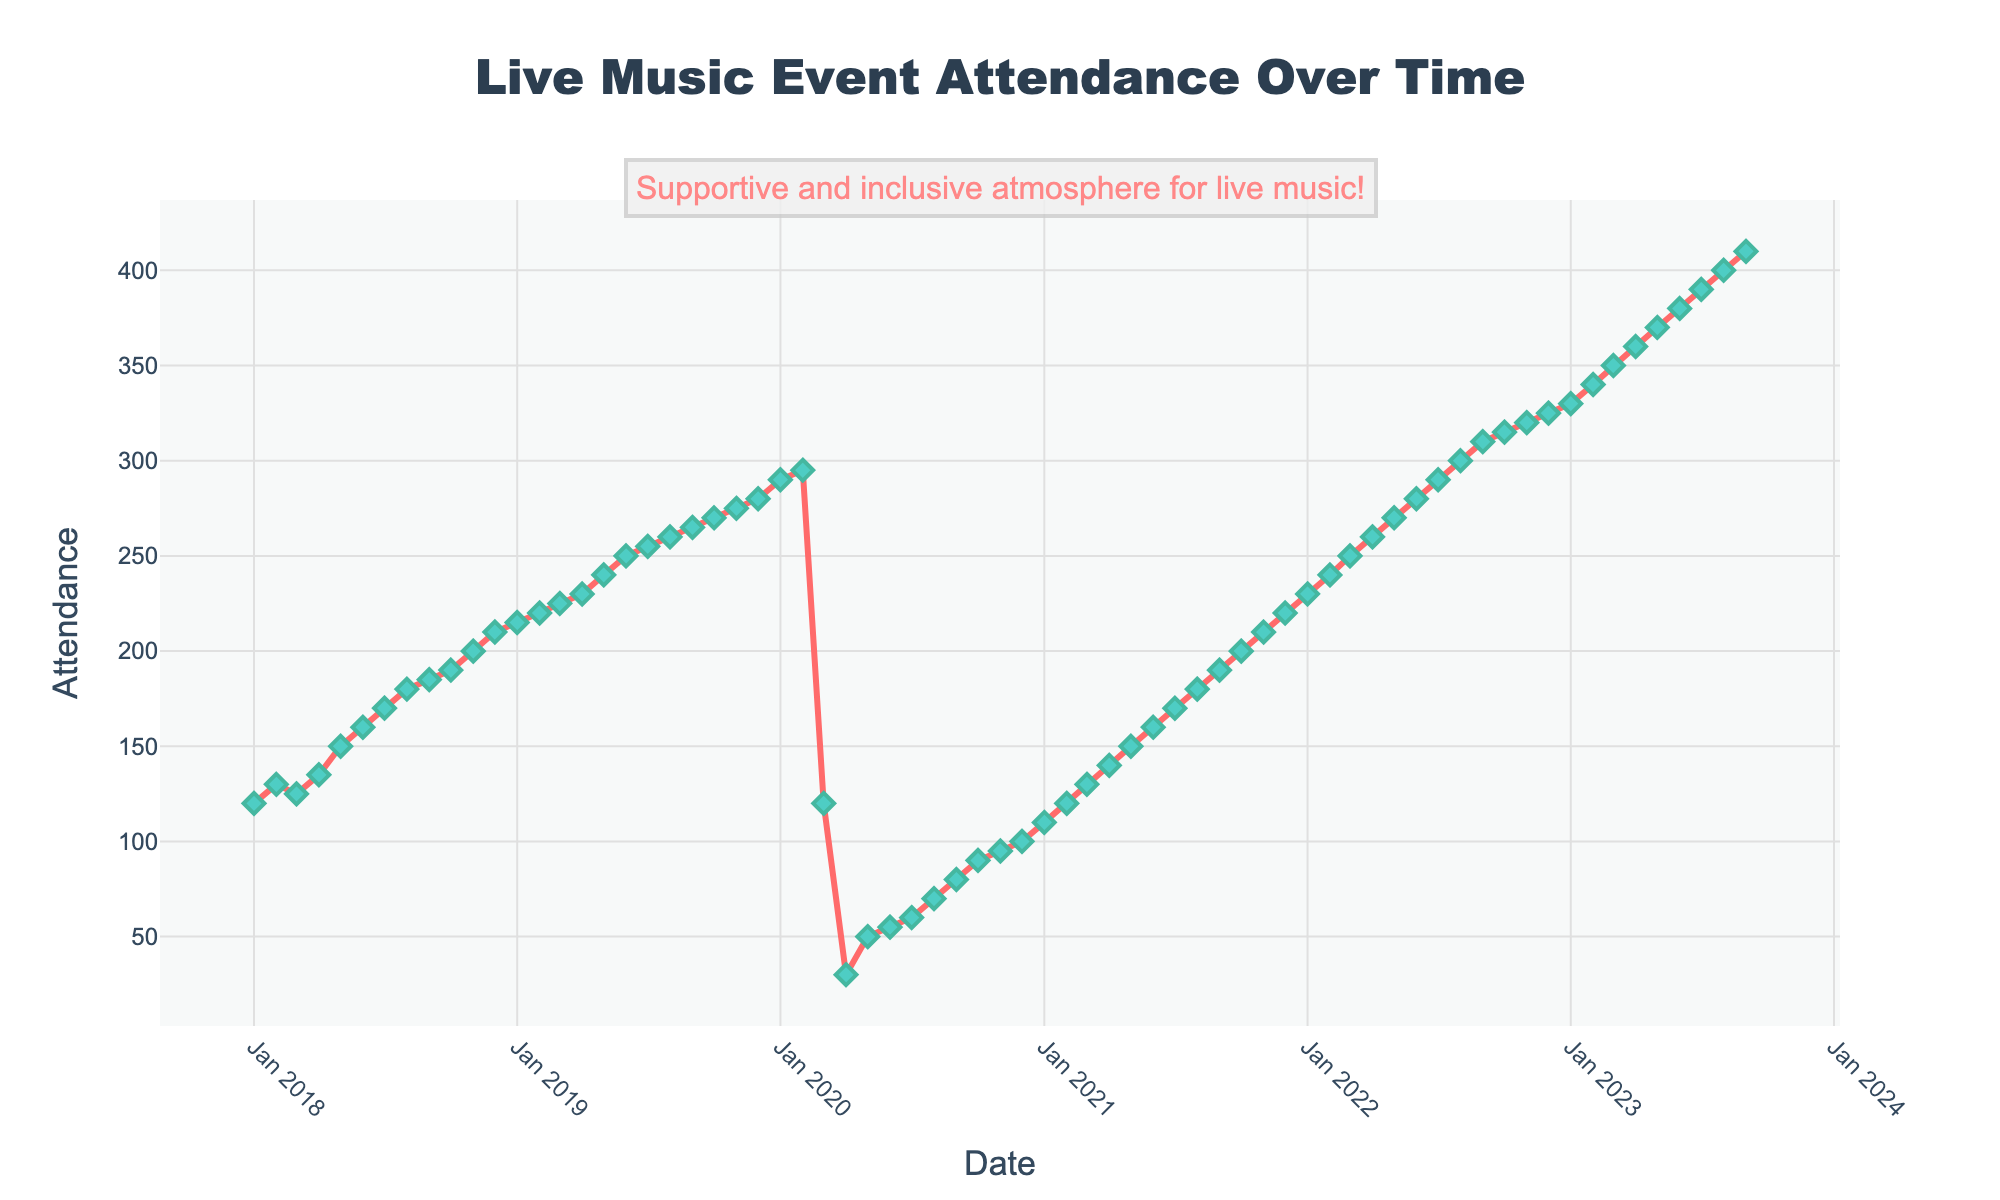How many distinct data points are plotted on the graph? The data spans from January 2018 to September 2023. Each month between these dates corresponds to one data point.
Answer: 69 What is the title of the plot? The plot title is placed at the top center of the figure.
Answer: Live Music Event Attendance Over Time What were the attendance numbers for March 2020? By locating March 2020 on the x-axis and checking the corresponding attendance value on the y-axis, we see it significantly dropped.
Answer: 120 How does the attendance in April 2023 compare to that in April 2020? Locate April 2023 and April 2020 on the x-axis, compare their corresponding y-axis values: April 2023 is much higher.
Answer: 360 vs. 30 What trend is noticeable from March 2020 to December 2020? Following the attendance from March 2020 to December 2020, we observe a steep initial drop and then a gradual increase.
Answer: A steep drop followed by gradual recovery How much did the attendance increase from December 2019 to December 2020? Attendance in December 2019 was 280, and in December 2020, it was 100. The difference is 280 - 100.
Answer: 180 decrease What is the average attendance for the first six months of 2023? Add attendance for January to June 2023 and divide by 6. (330 + 340 + 350 + 360 + 370 + 380) / 6 = 355
Answer: 355 Describe the attendance pattern from 2021 to 2022. From January 2021 to December 2022, attendance consistently increases each month after rebounding from the 2020 drop.
Answer: Consistent increase Which month had the highest attendance recorded, and what was the value? Track all data points, the highest y-axis value is for September 2023.
Answer: September 2023 with 410 What might have caused the significant drop in March 2020, and how did it recover afterward? March 2020 aligns with the global COVID-19 pandemic outbreak, causing lockdowns; gradual recovery likely due to easing restrictions.
Answer: COVID-19 pandemic and easing restrictions 